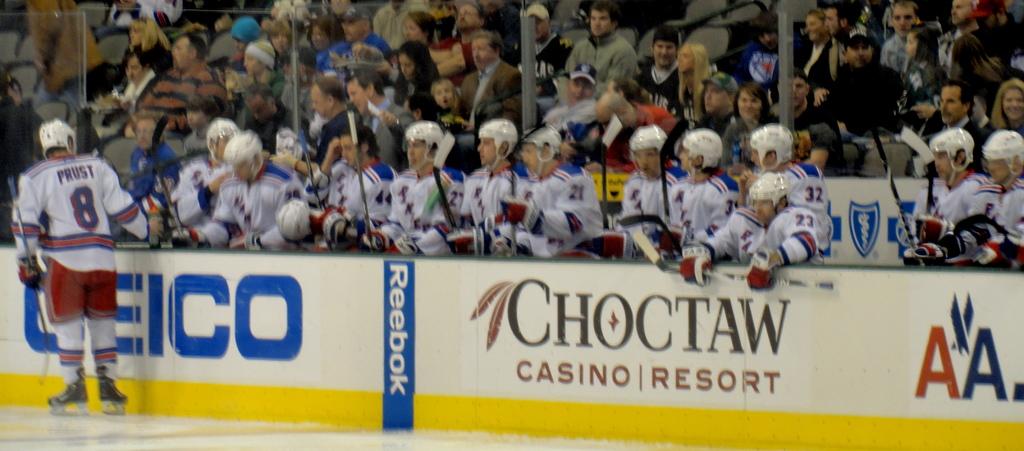What is player #8's name?
Your response must be concise. Prust. What tribe owns the casino and resort?
Offer a terse response. Choctaw. 